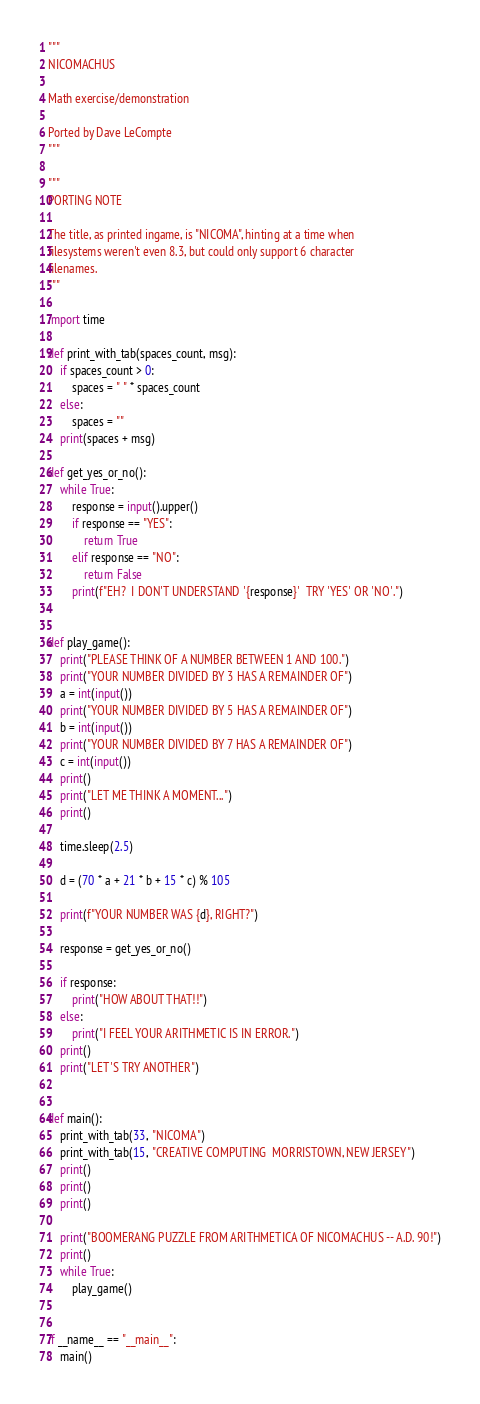<code> <loc_0><loc_0><loc_500><loc_500><_Python_>"""
NICOMACHUS

Math exercise/demonstration

Ported by Dave LeCompte
"""

"""
PORTING NOTE

The title, as printed ingame, is "NICOMA", hinting at a time when
filesystems weren't even 8.3, but could only support 6 character
filenames.
"""

import time

def print_with_tab(spaces_count, msg):
    if spaces_count > 0:
        spaces = " " * spaces_count
    else:
        spaces = ""
    print(spaces + msg)

def get_yes_or_no():
    while True:
        response = input().upper()
        if response == "YES":
            return True
        elif response == "NO":
            return False
        print(f"EH?  I DON'T UNDERSTAND '{response}'  TRY 'YES' OR 'NO'.")


def play_game():
    print("PLEASE THINK OF A NUMBER BETWEEN 1 AND 100.")
    print("YOUR NUMBER DIVIDED BY 3 HAS A REMAINDER OF")
    a = int(input())
    print("YOUR NUMBER DIVIDED BY 5 HAS A REMAINDER OF")
    b = int(input())
    print("YOUR NUMBER DIVIDED BY 7 HAS A REMAINDER OF")
    c = int(input())
    print()
    print("LET ME THINK A MOMENT...")
    print()

    time.sleep(2.5)

    d = (70 * a + 21 * b + 15 * c) % 105

    print(f"YOUR NUMBER WAS {d}, RIGHT?")

    response = get_yes_or_no()

    if response:
        print("HOW ABOUT THAT!!")
    else:
        print("I FEEL YOUR ARITHMETIC IS IN ERROR.")
    print()
    print("LET'S TRY ANOTHER")
    

def main():
    print_with_tab(33, "NICOMA")
    print_with_tab(15, "CREATIVE COMPUTING  MORRISTOWN, NEW JERSEY")
    print()
    print()
    print()
    
    print("BOOMERANG PUZZLE FROM ARITHMETICA OF NICOMACHUS -- A.D. 90!")
    print()
    while True:
        play_game()
        

if __name__ == "__main__":
    main()
</code> 